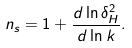Convert formula to latex. <formula><loc_0><loc_0><loc_500><loc_500>n _ { s } = 1 + \frac { d \ln \delta _ { H } ^ { 2 } } { d \ln k } .</formula> 